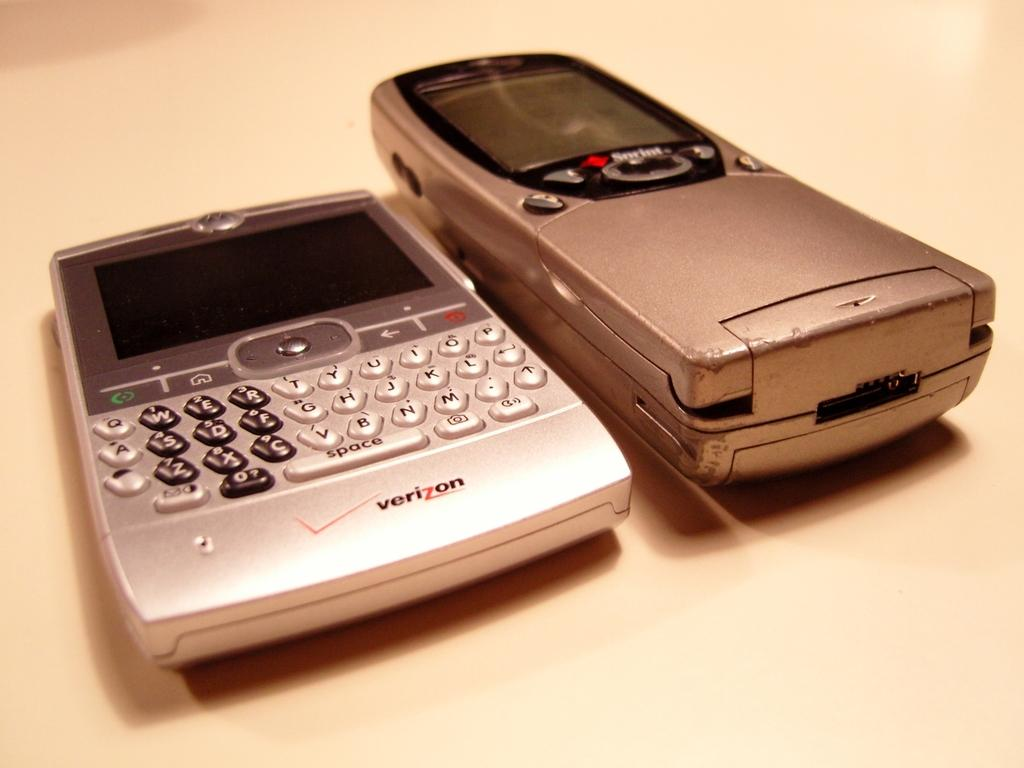Provide a one-sentence caption for the provided image. A Sprint phone and a Verizon device sit side by side. 